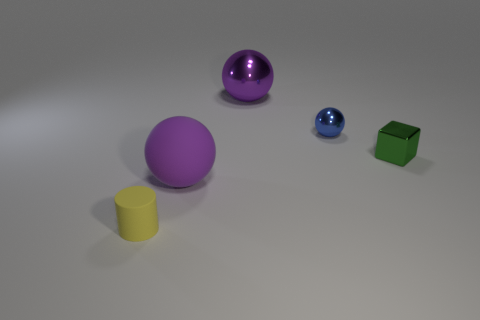What number of big matte objects are the same color as the cube?
Your answer should be very brief. 0. The object that is both in front of the small blue metal sphere and behind the rubber sphere has what shape?
Give a very brief answer. Cube. What is the color of the object that is to the right of the small yellow object and left of the big metal thing?
Ensure brevity in your answer.  Purple. Is the number of small metal blocks that are to the left of the purple shiny sphere greater than the number of small blue metal balls behind the cylinder?
Your answer should be very brief. No. The big object in front of the tiny blue sphere is what color?
Offer a terse response. Purple. There is a small object that is on the left side of the small blue object; does it have the same shape as the matte thing that is behind the yellow matte cylinder?
Your answer should be very brief. No. Are there any other purple rubber cylinders that have the same size as the rubber cylinder?
Your answer should be compact. No. There is a large object that is left of the large purple shiny thing; what is its material?
Your response must be concise. Rubber. Does the purple thing that is in front of the blue ball have the same material as the tiny green thing?
Offer a very short reply. No. Is there a cyan metallic sphere?
Your answer should be compact. No. 